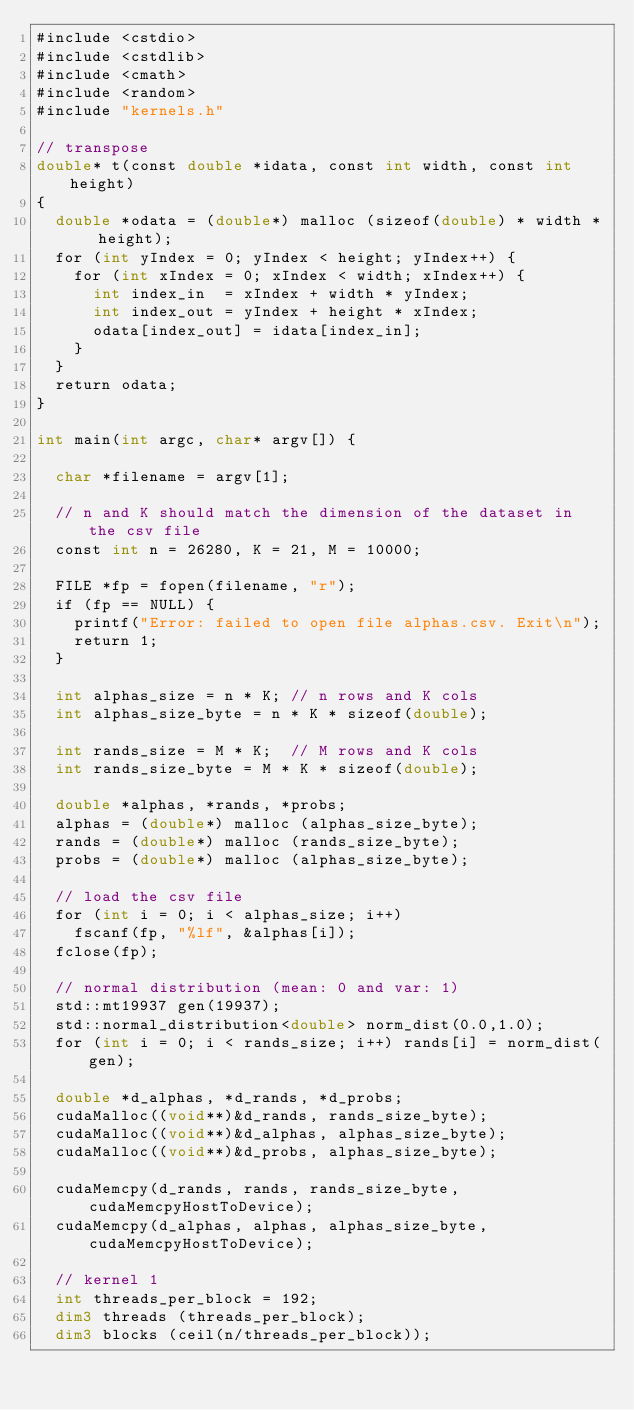Convert code to text. <code><loc_0><loc_0><loc_500><loc_500><_Cuda_>#include <cstdio>
#include <cstdlib>
#include <cmath>
#include <random>
#include "kernels.h"

// transpose
double* t(const double *idata, const int width, const int height)
{
  double *odata = (double*) malloc (sizeof(double) * width * height); 
  for (int yIndex = 0; yIndex < height; yIndex++) {
    for (int xIndex = 0; xIndex < width; xIndex++) {
      int index_in  = xIndex + width * yIndex;
      int index_out = yIndex + height * xIndex;
      odata[index_out] = idata[index_in];
    }
  }
  return odata;
}

int main(int argc, char* argv[]) {

  char *filename = argv[1];

  // n and K should match the dimension of the dataset in the csv file
  const int n = 26280, K = 21, M = 10000;

  FILE *fp = fopen(filename, "r");
  if (fp == NULL) {
    printf("Error: failed to open file alphas.csv. Exit\n");
    return 1;
  }

  int alphas_size = n * K; // n rows and K cols
  int alphas_size_byte = n * K * sizeof(double);

  int rands_size = M * K;  // M rows and K cols
  int rands_size_byte = M * K * sizeof(double);

  double *alphas, *rands, *probs;
  alphas = (double*) malloc (alphas_size_byte);
  rands = (double*) malloc (rands_size_byte);
  probs = (double*) malloc (alphas_size_byte);

  // load the csv file 
  for (int i = 0; i < alphas_size; i++)
    fscanf(fp, "%lf", &alphas[i]);
  fclose(fp);

  // normal distribution (mean: 0 and var: 1)
  std::mt19937 gen(19937);
  std::normal_distribution<double> norm_dist(0.0,1.0);
  for (int i = 0; i < rands_size; i++) rands[i] = norm_dist(gen); 

  double *d_alphas, *d_rands, *d_probs;
  cudaMalloc((void**)&d_rands, rands_size_byte);
  cudaMalloc((void**)&d_alphas, alphas_size_byte);
  cudaMalloc((void**)&d_probs, alphas_size_byte);

  cudaMemcpy(d_rands, rands, rands_size_byte, cudaMemcpyHostToDevice);
  cudaMemcpy(d_alphas, alphas, alphas_size_byte, cudaMemcpyHostToDevice);

  // kernel 1
  int threads_per_block = 192;
  dim3 threads (threads_per_block);
  dim3 blocks (ceil(n/threads_per_block));
</code> 